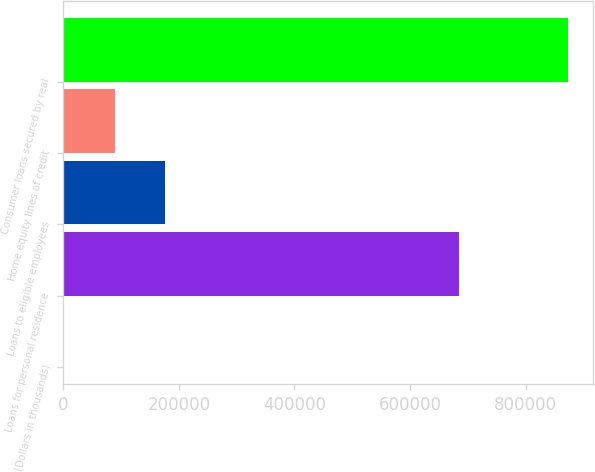Convert chart. <chart><loc_0><loc_0><loc_500><loc_500><bar_chart><fcel>(Dollars in thousands)<fcel>Loans for personal residence<fcel>Loans to eligible employees<fcel>Home equity lines of credit<fcel>Consumer loans secured by real<nl><fcel>2013<fcel>685327<fcel>176261<fcel>89137.2<fcel>873255<nl></chart> 